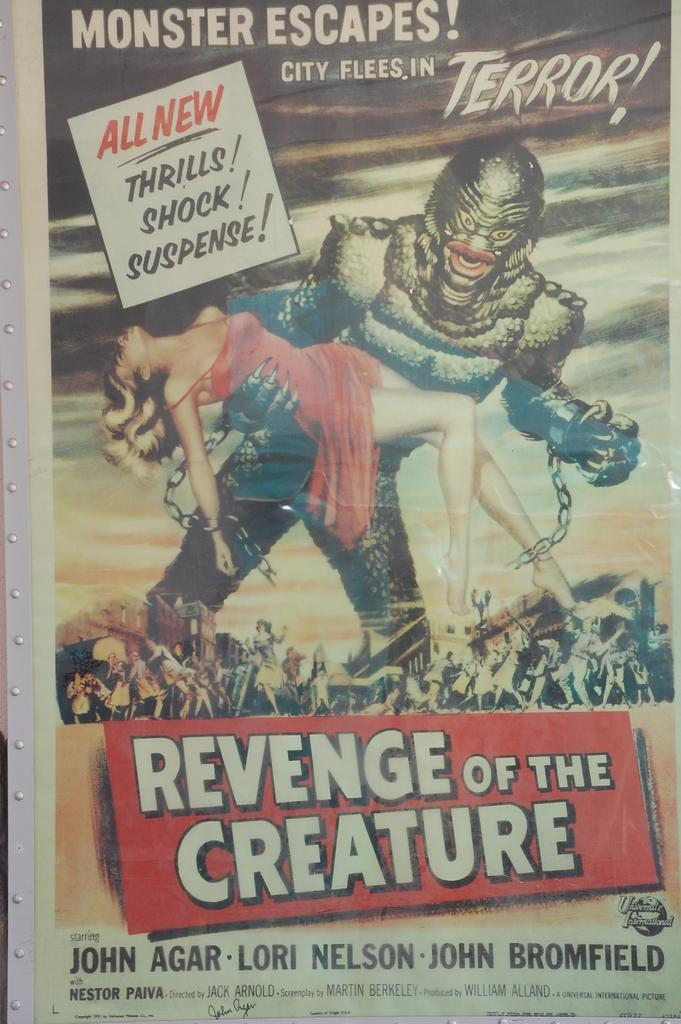Provide a one-sentence caption for the provided image. A poster for the movie "Revenge of the Creature" featuring a woman being held by a monster in chains. 